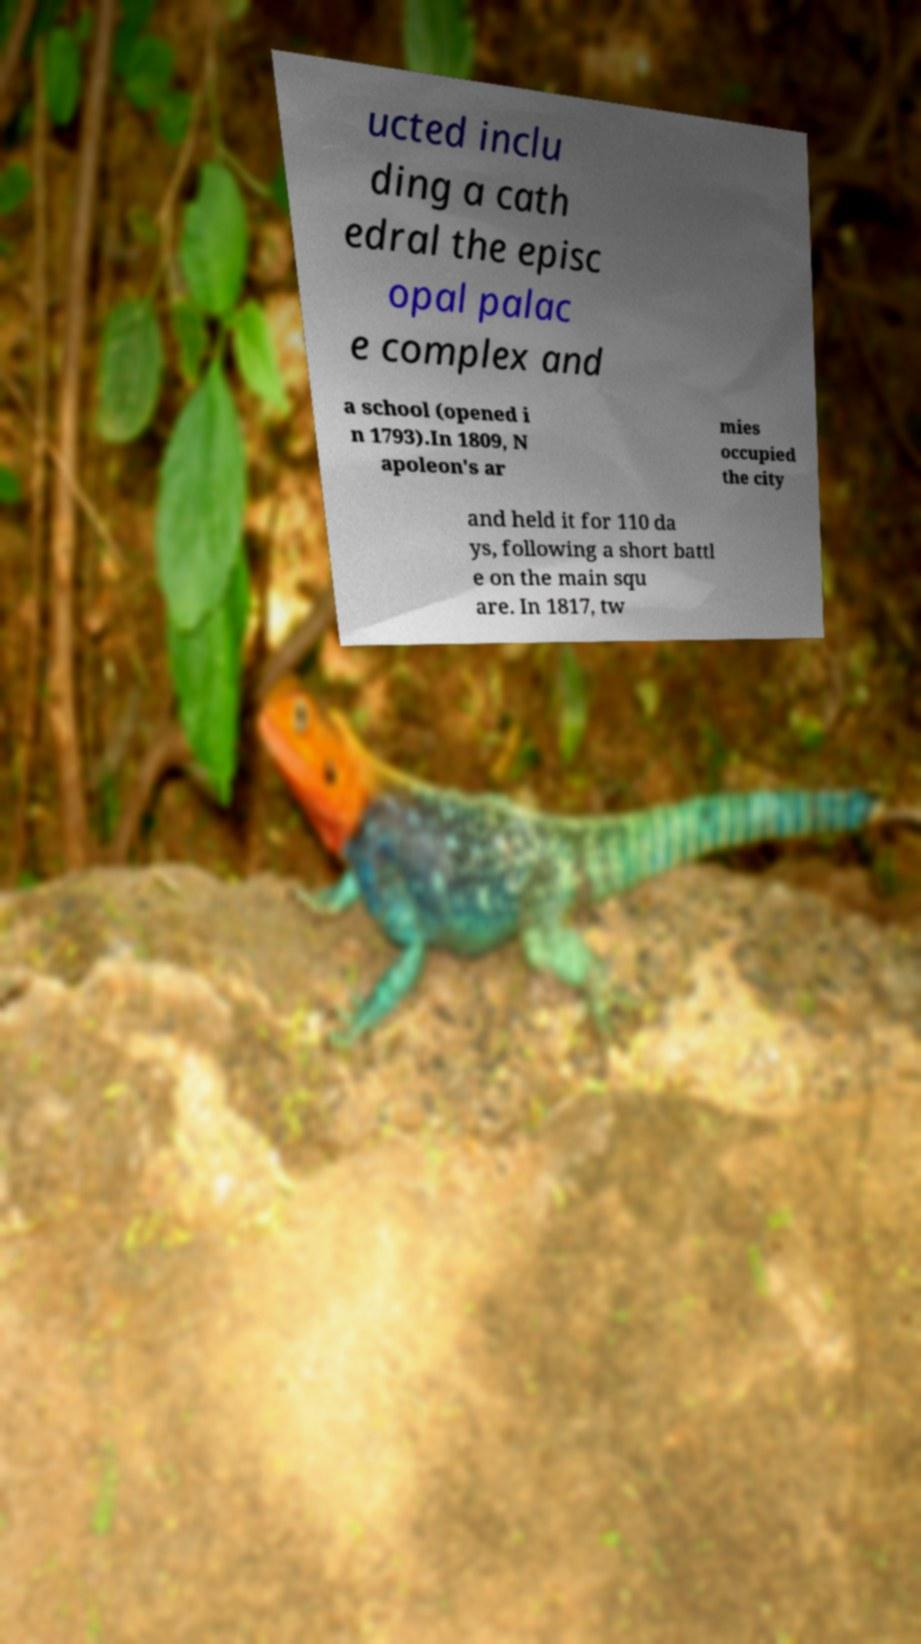There's text embedded in this image that I need extracted. Can you transcribe it verbatim? ucted inclu ding a cath edral the episc opal palac e complex and a school (opened i n 1793).In 1809, N apoleon's ar mies occupied the city and held it for 110 da ys, following a short battl e on the main squ are. In 1817, tw 